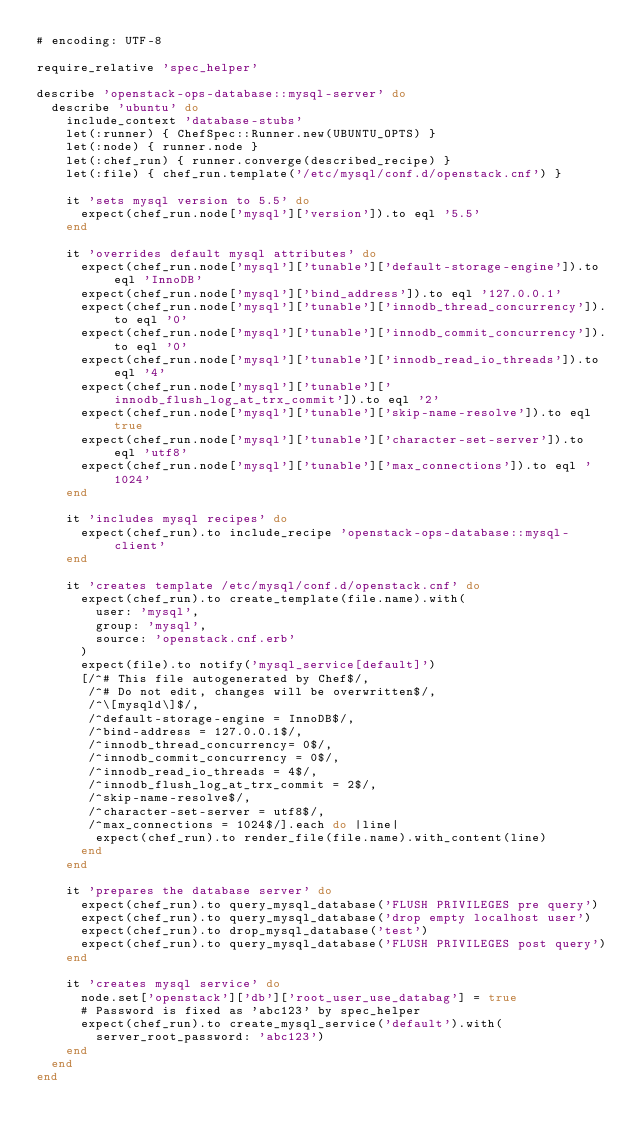<code> <loc_0><loc_0><loc_500><loc_500><_Ruby_># encoding: UTF-8

require_relative 'spec_helper'

describe 'openstack-ops-database::mysql-server' do
  describe 'ubuntu' do
    include_context 'database-stubs'
    let(:runner) { ChefSpec::Runner.new(UBUNTU_OPTS) }
    let(:node) { runner.node }
    let(:chef_run) { runner.converge(described_recipe) }
    let(:file) { chef_run.template('/etc/mysql/conf.d/openstack.cnf') }

    it 'sets mysql version to 5.5' do
      expect(chef_run.node['mysql']['version']).to eql '5.5'
    end

    it 'overrides default mysql attributes' do
      expect(chef_run.node['mysql']['tunable']['default-storage-engine']).to eql 'InnoDB'
      expect(chef_run.node['mysql']['bind_address']).to eql '127.0.0.1'
      expect(chef_run.node['mysql']['tunable']['innodb_thread_concurrency']).to eql '0'
      expect(chef_run.node['mysql']['tunable']['innodb_commit_concurrency']).to eql '0'
      expect(chef_run.node['mysql']['tunable']['innodb_read_io_threads']).to eql '4'
      expect(chef_run.node['mysql']['tunable']['innodb_flush_log_at_trx_commit']).to eql '2'
      expect(chef_run.node['mysql']['tunable']['skip-name-resolve']).to eql true
      expect(chef_run.node['mysql']['tunable']['character-set-server']).to eql 'utf8'
      expect(chef_run.node['mysql']['tunable']['max_connections']).to eql '1024'
    end

    it 'includes mysql recipes' do
      expect(chef_run).to include_recipe 'openstack-ops-database::mysql-client'
    end

    it 'creates template /etc/mysql/conf.d/openstack.cnf' do
      expect(chef_run).to create_template(file.name).with(
        user: 'mysql',
        group: 'mysql',
        source: 'openstack.cnf.erb'
      )
      expect(file).to notify('mysql_service[default]')
      [/^# This file autogenerated by Chef$/,
       /^# Do not edit, changes will be overwritten$/,
       /^\[mysqld\]$/,
       /^default-storage-engine = InnoDB$/,
       /^bind-address = 127.0.0.1$/,
       /^innodb_thread_concurrency= 0$/,
       /^innodb_commit_concurrency = 0$/,
       /^innodb_read_io_threads = 4$/,
       /^innodb_flush_log_at_trx_commit = 2$/,
       /^skip-name-resolve$/,
       /^character-set-server = utf8$/,
       /^max_connections = 1024$/].each do |line|
        expect(chef_run).to render_file(file.name).with_content(line)
      end
    end

    it 'prepares the database server' do
      expect(chef_run).to query_mysql_database('FLUSH PRIVILEGES pre query')
      expect(chef_run).to query_mysql_database('drop empty localhost user')
      expect(chef_run).to drop_mysql_database('test')
      expect(chef_run).to query_mysql_database('FLUSH PRIVILEGES post query')
    end

    it 'creates mysql service' do
      node.set['openstack']['db']['root_user_use_databag'] = true
      # Password is fixed as 'abc123' by spec_helper
      expect(chef_run).to create_mysql_service('default').with(
        server_root_password: 'abc123')
    end
  end
end
</code> 